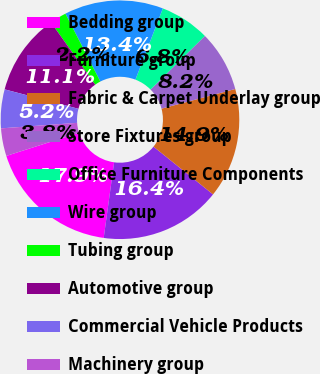<chart> <loc_0><loc_0><loc_500><loc_500><pie_chart><fcel>Bedding group<fcel>Furniture group<fcel>Fabric & Carpet Underlay group<fcel>Store Fixtures group<fcel>Office Furniture Components<fcel>Wire group<fcel>Tubing group<fcel>Automotive group<fcel>Commercial Vehicle Products<fcel>Machinery group<nl><fcel>17.92%<fcel>16.42%<fcel>14.91%<fcel>8.25%<fcel>6.75%<fcel>13.41%<fcel>2.25%<fcel>11.09%<fcel>5.25%<fcel>3.75%<nl></chart> 